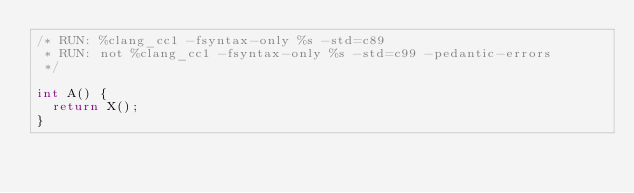Convert code to text. <code><loc_0><loc_0><loc_500><loc_500><_C_>/* RUN: %clang_cc1 -fsyntax-only %s -std=c89
 * RUN: not %clang_cc1 -fsyntax-only %s -std=c99 -pedantic-errors
 */

int A() {
  return X();
}

</code> 